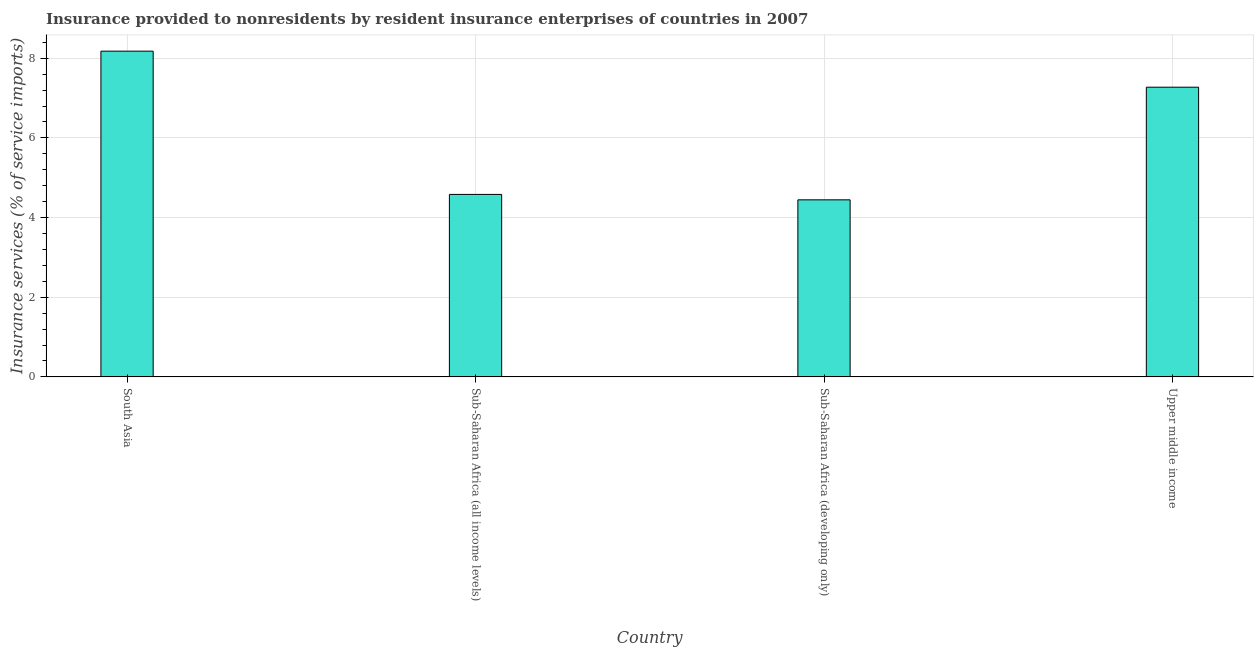Does the graph contain grids?
Make the answer very short. Yes. What is the title of the graph?
Offer a terse response. Insurance provided to nonresidents by resident insurance enterprises of countries in 2007. What is the label or title of the Y-axis?
Offer a terse response. Insurance services (% of service imports). What is the insurance and financial services in South Asia?
Your answer should be very brief. 8.18. Across all countries, what is the maximum insurance and financial services?
Make the answer very short. 8.18. Across all countries, what is the minimum insurance and financial services?
Keep it short and to the point. 4.44. In which country was the insurance and financial services maximum?
Your answer should be very brief. South Asia. In which country was the insurance and financial services minimum?
Your answer should be very brief. Sub-Saharan Africa (developing only). What is the sum of the insurance and financial services?
Provide a succinct answer. 24.48. What is the difference between the insurance and financial services in Sub-Saharan Africa (all income levels) and Sub-Saharan Africa (developing only)?
Your answer should be compact. 0.14. What is the average insurance and financial services per country?
Provide a short and direct response. 6.12. What is the median insurance and financial services?
Your response must be concise. 5.93. What is the ratio of the insurance and financial services in Sub-Saharan Africa (developing only) to that in Upper middle income?
Your answer should be compact. 0.61. Is the insurance and financial services in South Asia less than that in Upper middle income?
Your answer should be compact. No. What is the difference between the highest and the second highest insurance and financial services?
Offer a very short reply. 0.91. Is the sum of the insurance and financial services in Sub-Saharan Africa (developing only) and Upper middle income greater than the maximum insurance and financial services across all countries?
Make the answer very short. Yes. What is the difference between the highest and the lowest insurance and financial services?
Provide a short and direct response. 3.73. In how many countries, is the insurance and financial services greater than the average insurance and financial services taken over all countries?
Offer a very short reply. 2. What is the Insurance services (% of service imports) of South Asia?
Offer a very short reply. 8.18. What is the Insurance services (% of service imports) of Sub-Saharan Africa (all income levels)?
Offer a terse response. 4.58. What is the Insurance services (% of service imports) of Sub-Saharan Africa (developing only)?
Make the answer very short. 4.44. What is the Insurance services (% of service imports) of Upper middle income?
Offer a very short reply. 7.27. What is the difference between the Insurance services (% of service imports) in South Asia and Sub-Saharan Africa (all income levels)?
Make the answer very short. 3.6. What is the difference between the Insurance services (% of service imports) in South Asia and Sub-Saharan Africa (developing only)?
Provide a succinct answer. 3.73. What is the difference between the Insurance services (% of service imports) in South Asia and Upper middle income?
Make the answer very short. 0.9. What is the difference between the Insurance services (% of service imports) in Sub-Saharan Africa (all income levels) and Sub-Saharan Africa (developing only)?
Your answer should be compact. 0.14. What is the difference between the Insurance services (% of service imports) in Sub-Saharan Africa (all income levels) and Upper middle income?
Keep it short and to the point. -2.69. What is the difference between the Insurance services (% of service imports) in Sub-Saharan Africa (developing only) and Upper middle income?
Give a very brief answer. -2.83. What is the ratio of the Insurance services (% of service imports) in South Asia to that in Sub-Saharan Africa (all income levels)?
Your answer should be very brief. 1.78. What is the ratio of the Insurance services (% of service imports) in South Asia to that in Sub-Saharan Africa (developing only)?
Your response must be concise. 1.84. What is the ratio of the Insurance services (% of service imports) in South Asia to that in Upper middle income?
Your answer should be compact. 1.12. What is the ratio of the Insurance services (% of service imports) in Sub-Saharan Africa (all income levels) to that in Sub-Saharan Africa (developing only)?
Ensure brevity in your answer.  1.03. What is the ratio of the Insurance services (% of service imports) in Sub-Saharan Africa (all income levels) to that in Upper middle income?
Keep it short and to the point. 0.63. What is the ratio of the Insurance services (% of service imports) in Sub-Saharan Africa (developing only) to that in Upper middle income?
Your answer should be very brief. 0.61. 